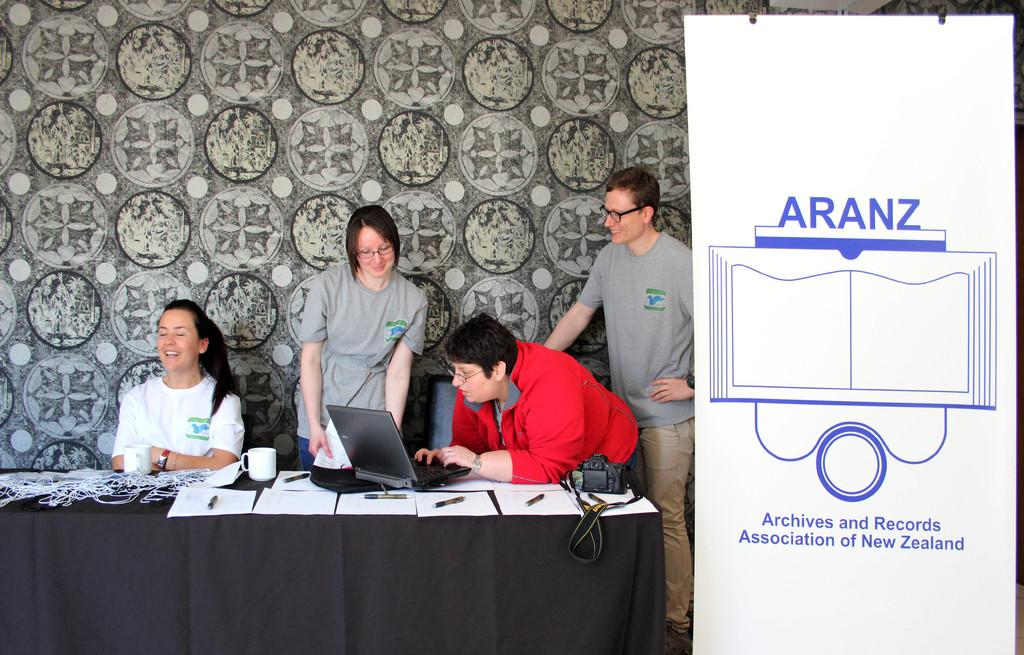How many people are in the image? There are four persons in the image. What is the main object in the image? There is a table in the image. What is covering the table? A cloth is present on the table. What items can be seen on the table? There are papers, pens, a cup, a camera, and a laptop on the table. What is hanging in the image? There is a banner in the image. What can be seen in the background of the image? There is a wall in the background of the image. What type of punishment is being discussed in the image? There is no indication of any punishment being discussed in the image. What type of house is visible in the image? There is no house visible in the image; it features a table with various items and a wall in the background. 